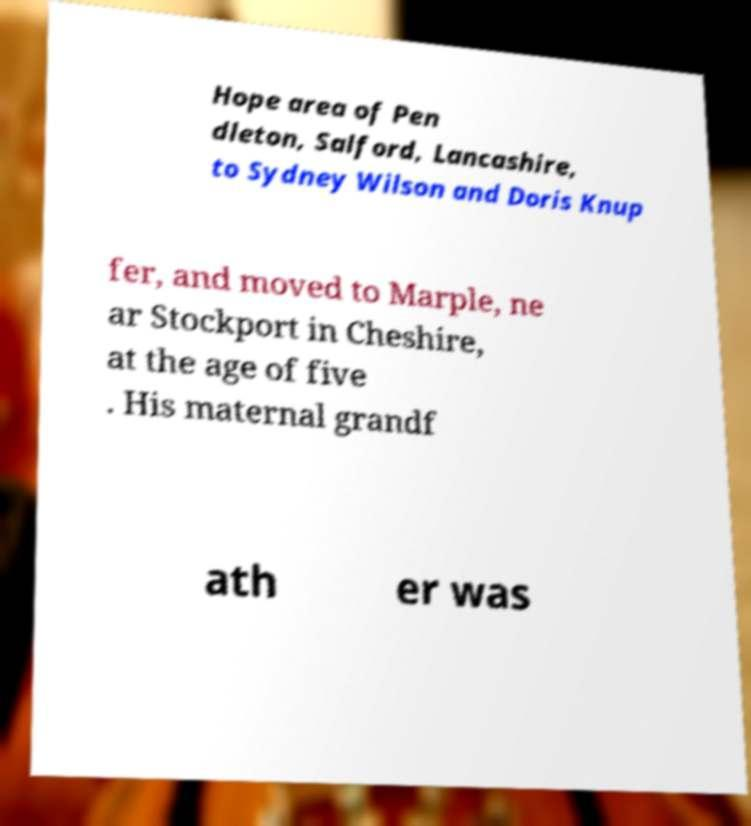Could you extract and type out the text from this image? Hope area of Pen dleton, Salford, Lancashire, to Sydney Wilson and Doris Knup fer, and moved to Marple, ne ar Stockport in Cheshire, at the age of five . His maternal grandf ath er was 